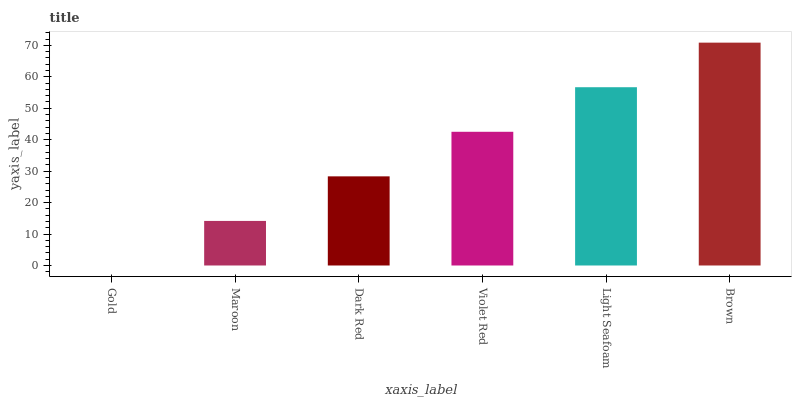Is Gold the minimum?
Answer yes or no. Yes. Is Brown the maximum?
Answer yes or no. Yes. Is Maroon the minimum?
Answer yes or no. No. Is Maroon the maximum?
Answer yes or no. No. Is Maroon greater than Gold?
Answer yes or no. Yes. Is Gold less than Maroon?
Answer yes or no. Yes. Is Gold greater than Maroon?
Answer yes or no. No. Is Maroon less than Gold?
Answer yes or no. No. Is Violet Red the high median?
Answer yes or no. Yes. Is Dark Red the low median?
Answer yes or no. Yes. Is Gold the high median?
Answer yes or no. No. Is Brown the low median?
Answer yes or no. No. 